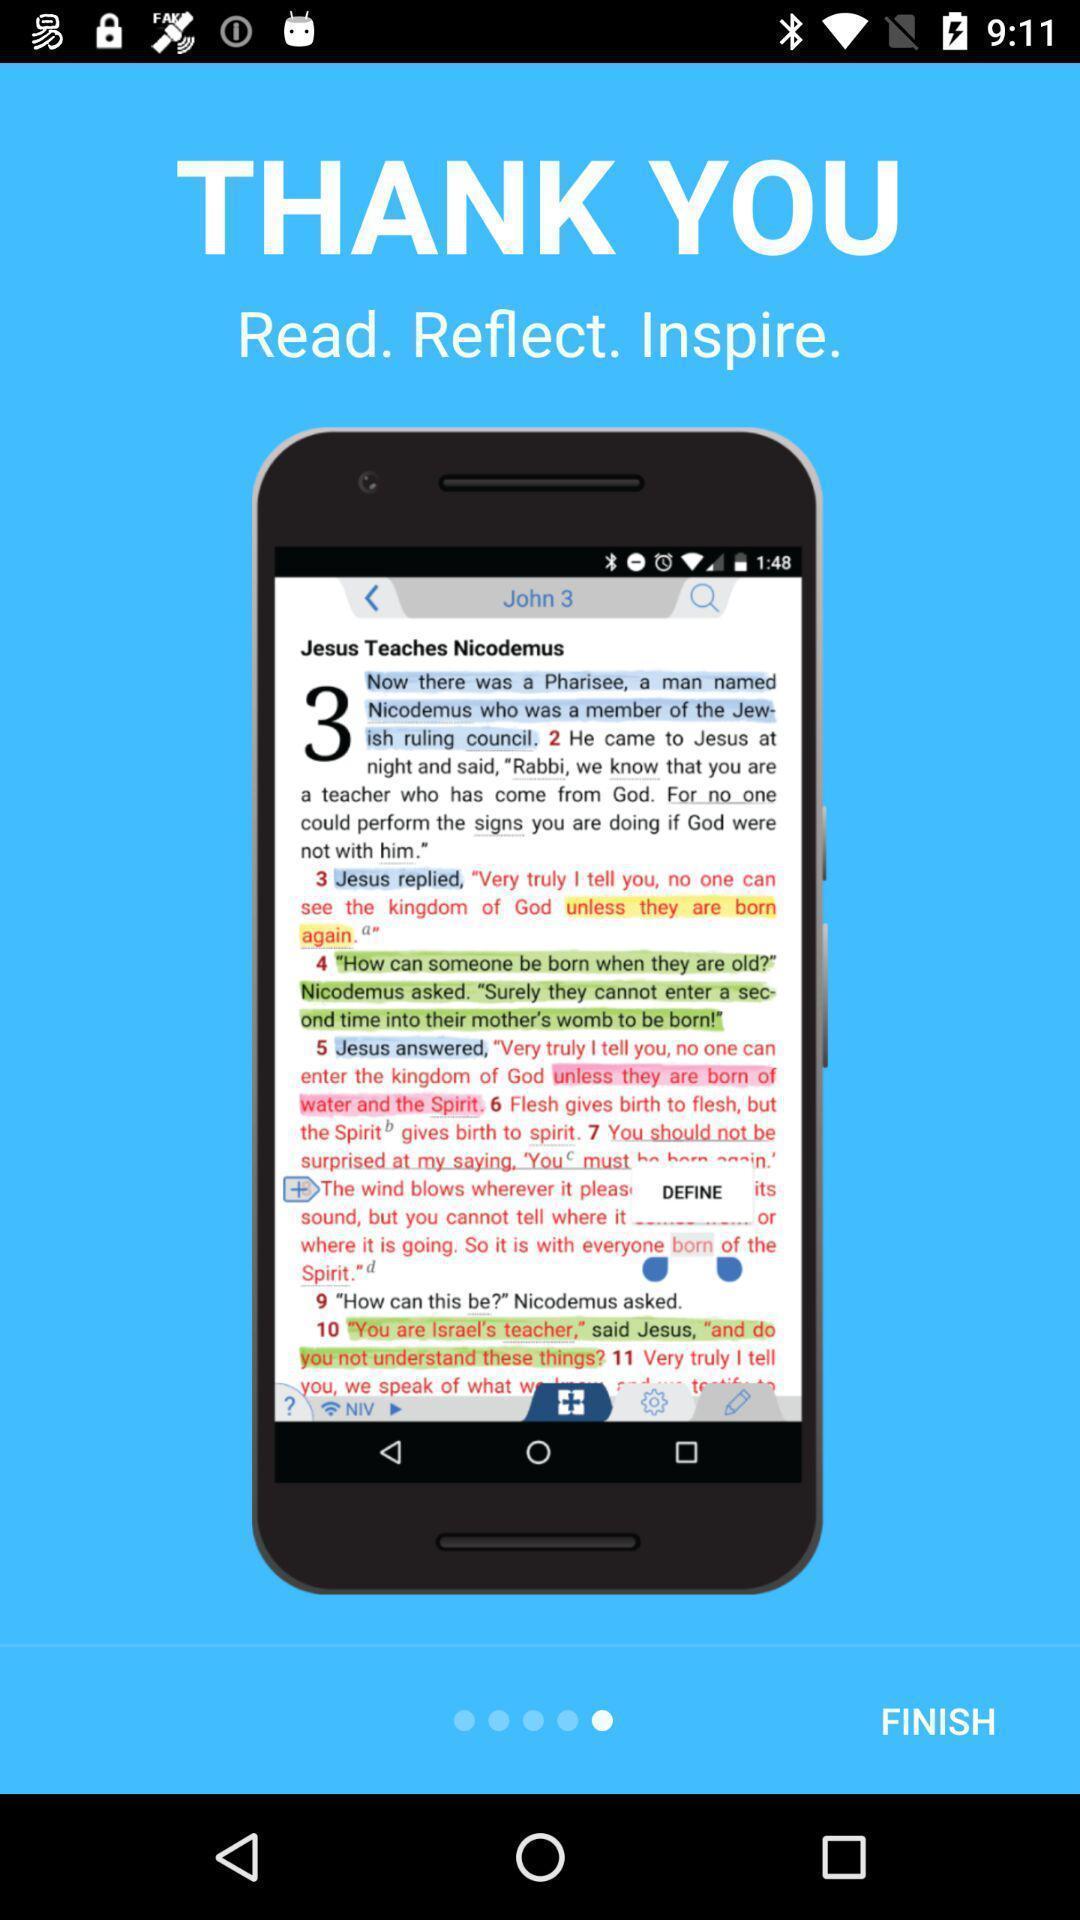Tell me about the visual elements in this screen capture. Thank you page of a bible reading app. 